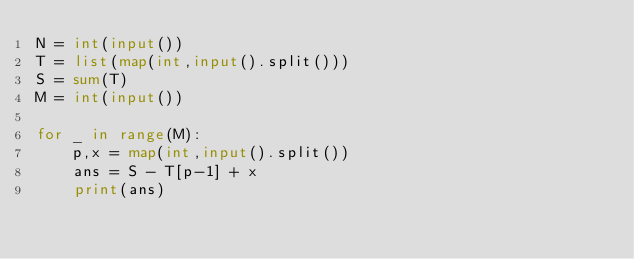<code> <loc_0><loc_0><loc_500><loc_500><_Python_>N = int(input())
T = list(map(int,input().split()))
S = sum(T)
M = int(input())

for _ in range(M):
    p,x = map(int,input().split())
    ans = S - T[p-1] + x
    print(ans)</code> 